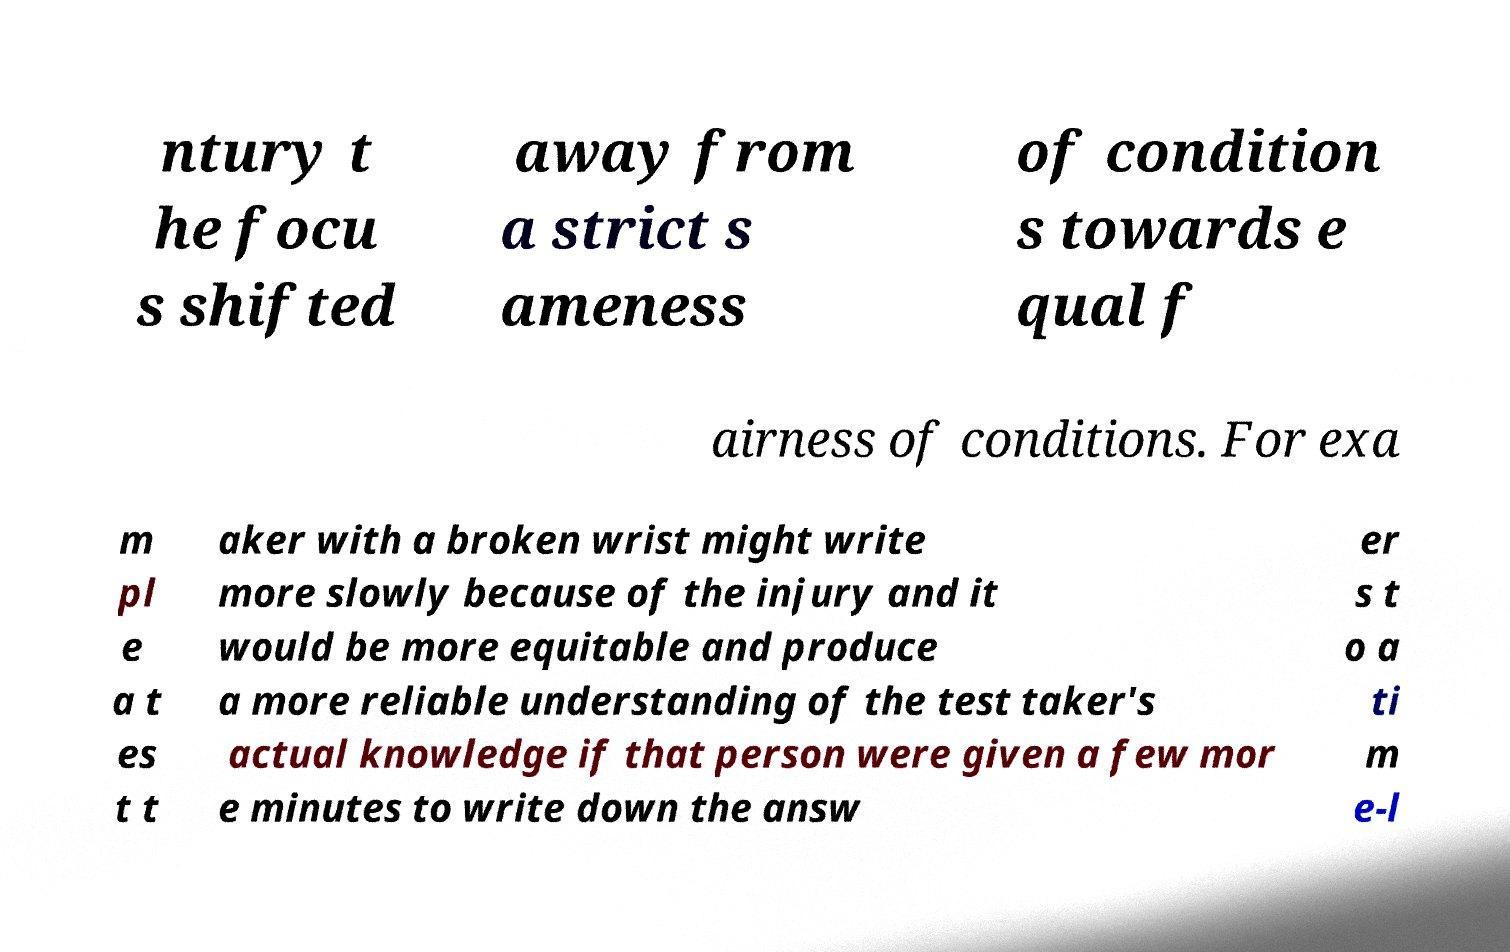What messages or text are displayed in this image? I need them in a readable, typed format. ntury t he focu s shifted away from a strict s ameness of condition s towards e qual f airness of conditions. For exa m pl e a t es t t aker with a broken wrist might write more slowly because of the injury and it would be more equitable and produce a more reliable understanding of the test taker's actual knowledge if that person were given a few mor e minutes to write down the answ er s t o a ti m e-l 